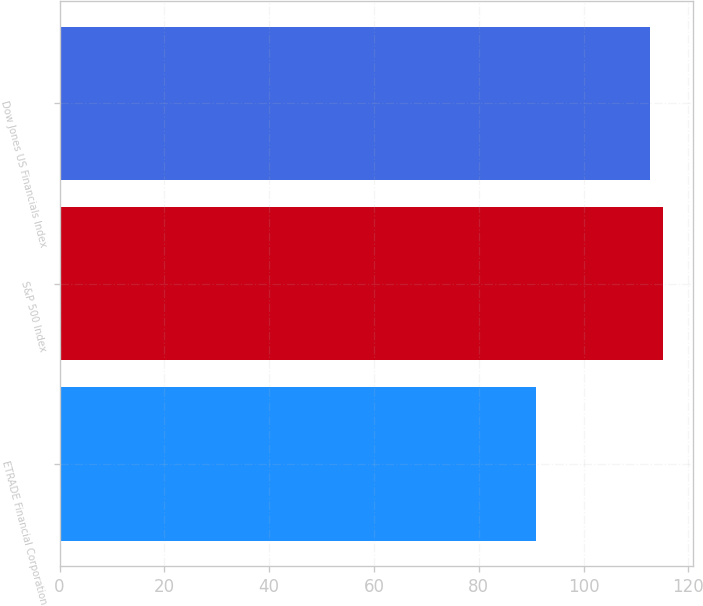Convert chart. <chart><loc_0><loc_0><loc_500><loc_500><bar_chart><fcel>ETRADE Financial Corporation<fcel>S&P 500 Index<fcel>Dow Jones US Financials Index<nl><fcel>90.91<fcel>115.14<fcel>112.72<nl></chart> 